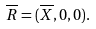Convert formula to latex. <formula><loc_0><loc_0><loc_500><loc_500>\overline { R } = ( \overline { X } , 0 , 0 ) .</formula> 